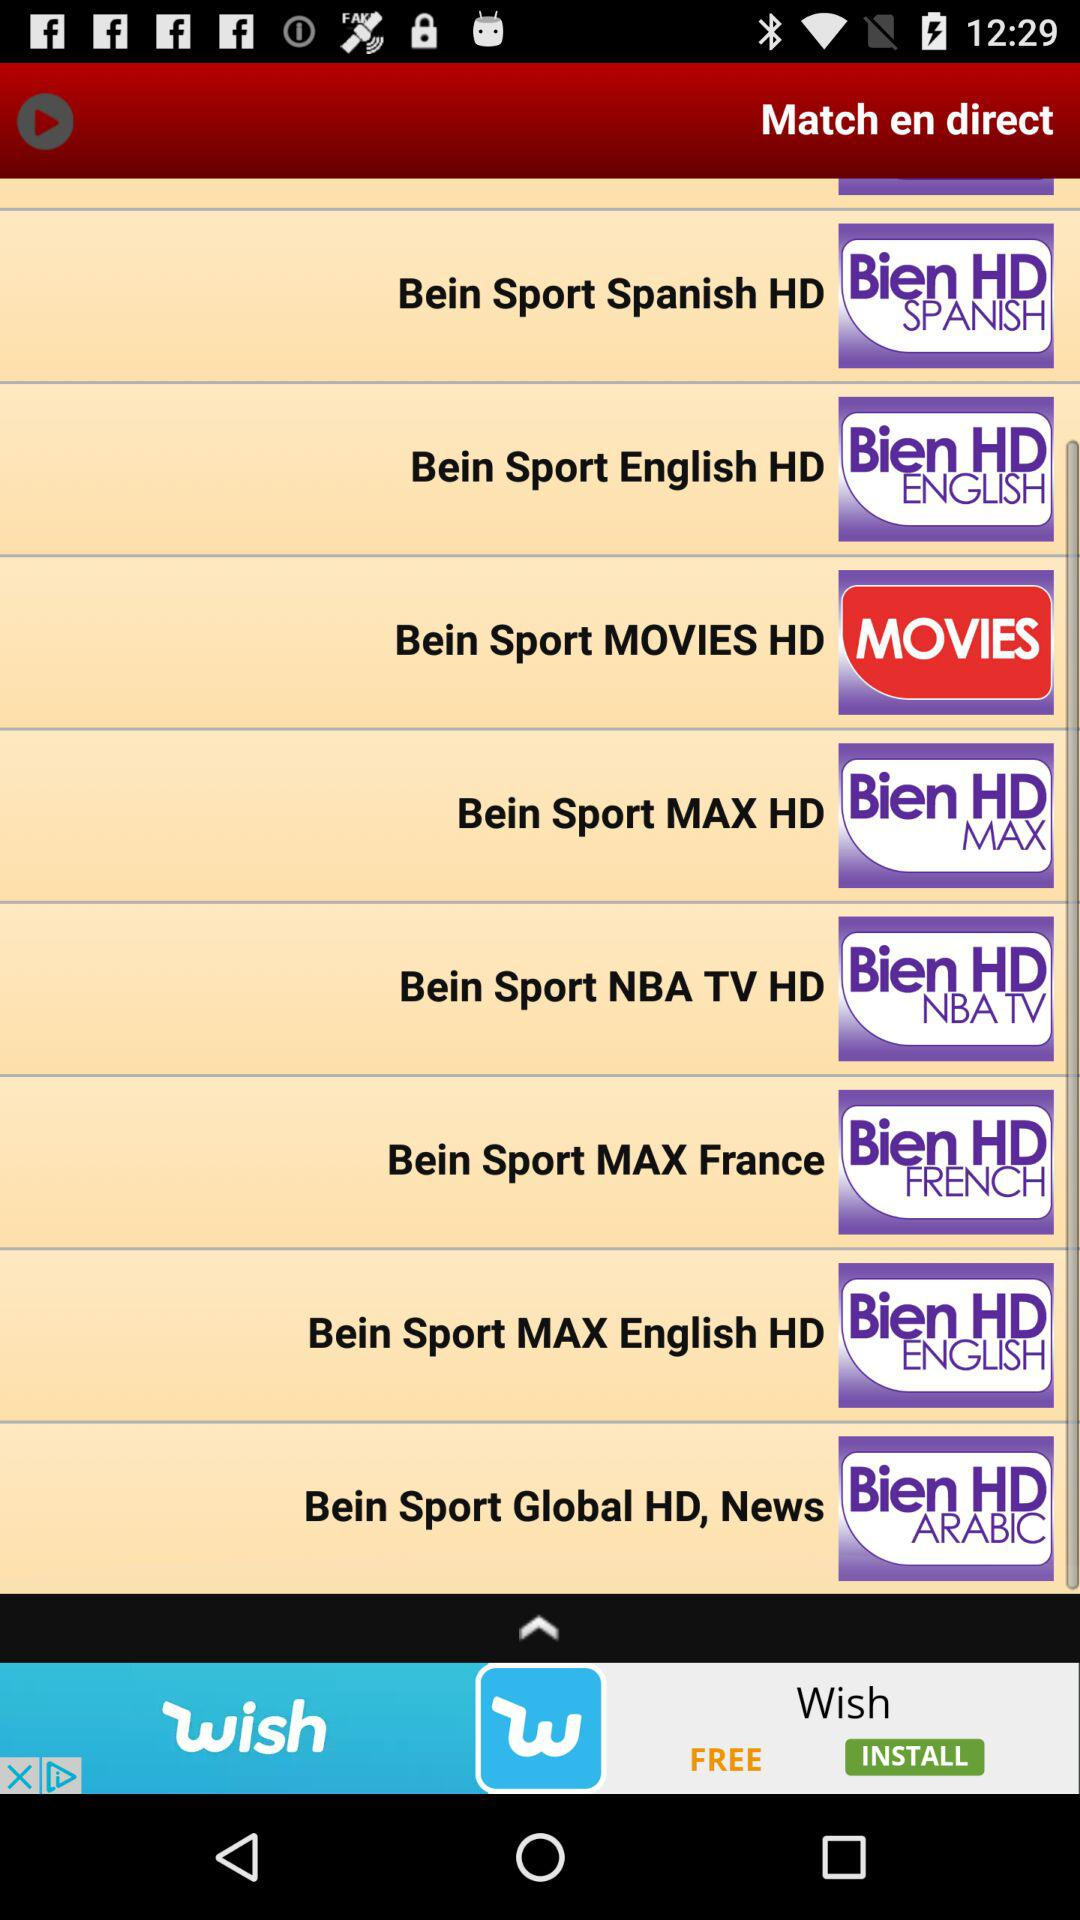Is there a channel dedicated to basketball fans, and if so, which one? Yes, for basketball enthusiasts, the 'Bein Sport NBA TV HD' channel listed in the image is dedicated to basketball, offering live games, highlights, and other basketball-related programming in high definition. 